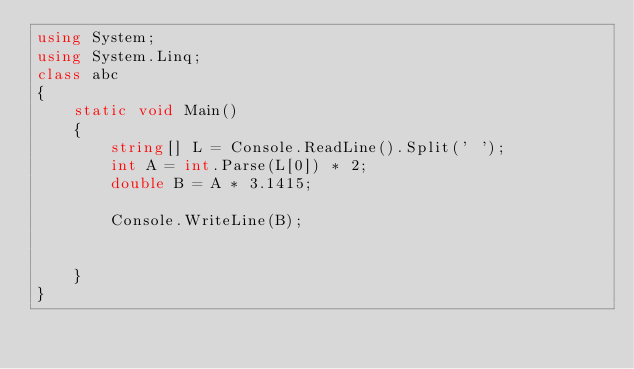Convert code to text. <code><loc_0><loc_0><loc_500><loc_500><_C#_>using System;
using System.Linq;
class abc
{
    static void Main()
    {
        string[] L = Console.ReadLine().Split(' ');
        int A = int.Parse(L[0]) * 2;
        double B = A * 3.1415;

        Console.WriteLine(B);


    }
}
</code> 